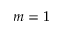<formula> <loc_0><loc_0><loc_500><loc_500>m = 1</formula> 